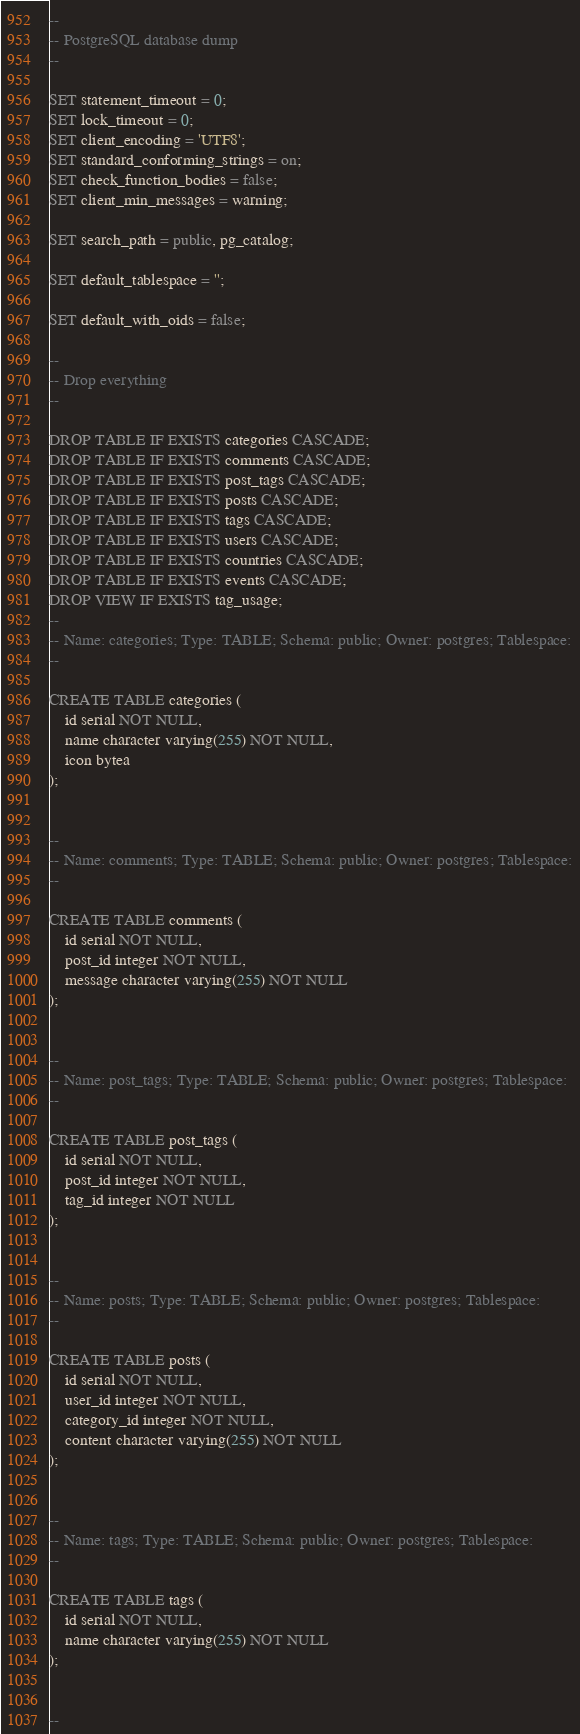Convert code to text. <code><loc_0><loc_0><loc_500><loc_500><_SQL_>--
-- PostgreSQL database dump
--

SET statement_timeout = 0;
SET lock_timeout = 0;
SET client_encoding = 'UTF8';
SET standard_conforming_strings = on;
SET check_function_bodies = false;
SET client_min_messages = warning;

SET search_path = public, pg_catalog;

SET default_tablespace = '';

SET default_with_oids = false;

--
-- Drop everything
--

DROP TABLE IF EXISTS categories CASCADE;
DROP TABLE IF EXISTS comments CASCADE;
DROP TABLE IF EXISTS post_tags CASCADE;
DROP TABLE IF EXISTS posts CASCADE;
DROP TABLE IF EXISTS tags CASCADE;
DROP TABLE IF EXISTS users CASCADE;
DROP TABLE IF EXISTS countries CASCADE;
DROP TABLE IF EXISTS events CASCADE;
DROP VIEW IF EXISTS tag_usage;
--
-- Name: categories; Type: TABLE; Schema: public; Owner: postgres; Tablespace:
--

CREATE TABLE categories (
    id serial NOT NULL,
    name character varying(255) NOT NULL,
    icon bytea
);


--
-- Name: comments; Type: TABLE; Schema: public; Owner: postgres; Tablespace:
--

CREATE TABLE comments (
    id serial NOT NULL,
    post_id integer NOT NULL,
    message character varying(255) NOT NULL
);


--
-- Name: post_tags; Type: TABLE; Schema: public; Owner: postgres; Tablespace:
--

CREATE TABLE post_tags (
    id serial NOT NULL,
    post_id integer NOT NULL,
    tag_id integer NOT NULL
);


--
-- Name: posts; Type: TABLE; Schema: public; Owner: postgres; Tablespace:
--

CREATE TABLE posts (
    id serial NOT NULL,
    user_id integer NOT NULL,
    category_id integer NOT NULL,
    content character varying(255) NOT NULL
);


--
-- Name: tags; Type: TABLE; Schema: public; Owner: postgres; Tablespace:
--

CREATE TABLE tags (
    id serial NOT NULL,
    name character varying(255) NOT NULL
);


--</code> 